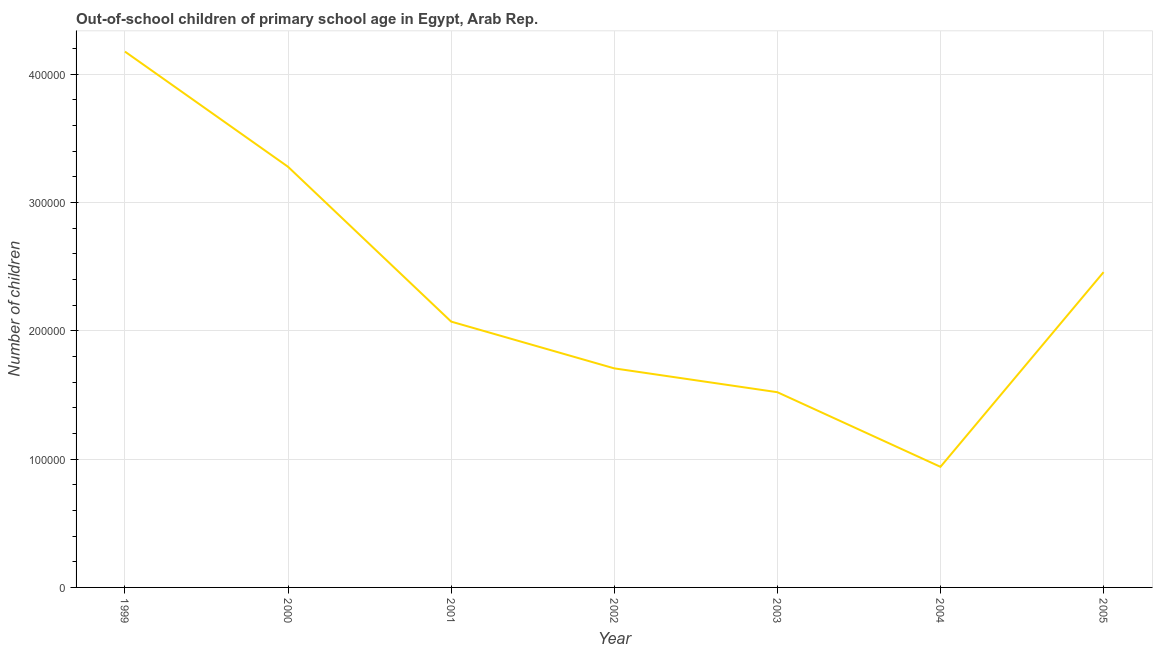What is the number of out-of-school children in 1999?
Your answer should be very brief. 4.18e+05. Across all years, what is the maximum number of out-of-school children?
Your answer should be very brief. 4.18e+05. Across all years, what is the minimum number of out-of-school children?
Your answer should be compact. 9.40e+04. In which year was the number of out-of-school children maximum?
Your answer should be compact. 1999. In which year was the number of out-of-school children minimum?
Provide a short and direct response. 2004. What is the sum of the number of out-of-school children?
Your response must be concise. 1.62e+06. What is the difference between the number of out-of-school children in 1999 and 2002?
Give a very brief answer. 2.47e+05. What is the average number of out-of-school children per year?
Ensure brevity in your answer.  2.31e+05. What is the median number of out-of-school children?
Offer a very short reply. 2.07e+05. Do a majority of the years between 1999 and 2000 (inclusive) have number of out-of-school children greater than 260000 ?
Offer a terse response. Yes. What is the ratio of the number of out-of-school children in 2002 to that in 2005?
Ensure brevity in your answer.  0.69. What is the difference between the highest and the second highest number of out-of-school children?
Give a very brief answer. 8.98e+04. What is the difference between the highest and the lowest number of out-of-school children?
Give a very brief answer. 3.24e+05. How many lines are there?
Your response must be concise. 1. How many years are there in the graph?
Give a very brief answer. 7. What is the difference between two consecutive major ticks on the Y-axis?
Offer a very short reply. 1.00e+05. Are the values on the major ticks of Y-axis written in scientific E-notation?
Your answer should be very brief. No. What is the title of the graph?
Give a very brief answer. Out-of-school children of primary school age in Egypt, Arab Rep. What is the label or title of the X-axis?
Your answer should be compact. Year. What is the label or title of the Y-axis?
Give a very brief answer. Number of children. What is the Number of children of 1999?
Your response must be concise. 4.18e+05. What is the Number of children in 2000?
Your response must be concise. 3.28e+05. What is the Number of children of 2001?
Ensure brevity in your answer.  2.07e+05. What is the Number of children of 2002?
Provide a succinct answer. 1.71e+05. What is the Number of children in 2003?
Give a very brief answer. 1.52e+05. What is the Number of children of 2004?
Give a very brief answer. 9.40e+04. What is the Number of children of 2005?
Provide a short and direct response. 2.46e+05. What is the difference between the Number of children in 1999 and 2000?
Your answer should be compact. 8.98e+04. What is the difference between the Number of children in 1999 and 2001?
Provide a succinct answer. 2.10e+05. What is the difference between the Number of children in 1999 and 2002?
Offer a terse response. 2.47e+05. What is the difference between the Number of children in 1999 and 2003?
Offer a terse response. 2.66e+05. What is the difference between the Number of children in 1999 and 2004?
Offer a terse response. 3.24e+05. What is the difference between the Number of children in 1999 and 2005?
Your answer should be very brief. 1.72e+05. What is the difference between the Number of children in 2000 and 2001?
Offer a terse response. 1.21e+05. What is the difference between the Number of children in 2000 and 2002?
Keep it short and to the point. 1.57e+05. What is the difference between the Number of children in 2000 and 2003?
Your response must be concise. 1.76e+05. What is the difference between the Number of children in 2000 and 2004?
Provide a succinct answer. 2.34e+05. What is the difference between the Number of children in 2000 and 2005?
Ensure brevity in your answer.  8.21e+04. What is the difference between the Number of children in 2001 and 2002?
Give a very brief answer. 3.65e+04. What is the difference between the Number of children in 2001 and 2003?
Your answer should be very brief. 5.50e+04. What is the difference between the Number of children in 2001 and 2004?
Give a very brief answer. 1.13e+05. What is the difference between the Number of children in 2001 and 2005?
Provide a short and direct response. -3.85e+04. What is the difference between the Number of children in 2002 and 2003?
Give a very brief answer. 1.86e+04. What is the difference between the Number of children in 2002 and 2004?
Make the answer very short. 7.68e+04. What is the difference between the Number of children in 2002 and 2005?
Offer a very short reply. -7.50e+04. What is the difference between the Number of children in 2003 and 2004?
Make the answer very short. 5.82e+04. What is the difference between the Number of children in 2003 and 2005?
Offer a very short reply. -9.36e+04. What is the difference between the Number of children in 2004 and 2005?
Your response must be concise. -1.52e+05. What is the ratio of the Number of children in 1999 to that in 2000?
Ensure brevity in your answer.  1.27. What is the ratio of the Number of children in 1999 to that in 2001?
Ensure brevity in your answer.  2.02. What is the ratio of the Number of children in 1999 to that in 2002?
Keep it short and to the point. 2.45. What is the ratio of the Number of children in 1999 to that in 2003?
Keep it short and to the point. 2.75. What is the ratio of the Number of children in 1999 to that in 2004?
Ensure brevity in your answer.  4.44. What is the ratio of the Number of children in 1999 to that in 2005?
Your answer should be very brief. 1.7. What is the ratio of the Number of children in 2000 to that in 2001?
Offer a very short reply. 1.58. What is the ratio of the Number of children in 2000 to that in 2002?
Give a very brief answer. 1.92. What is the ratio of the Number of children in 2000 to that in 2003?
Ensure brevity in your answer.  2.15. What is the ratio of the Number of children in 2000 to that in 2004?
Offer a terse response. 3.49. What is the ratio of the Number of children in 2000 to that in 2005?
Offer a terse response. 1.33. What is the ratio of the Number of children in 2001 to that in 2002?
Offer a terse response. 1.21. What is the ratio of the Number of children in 2001 to that in 2003?
Your answer should be very brief. 1.36. What is the ratio of the Number of children in 2001 to that in 2004?
Your answer should be compact. 2.2. What is the ratio of the Number of children in 2001 to that in 2005?
Provide a succinct answer. 0.84. What is the ratio of the Number of children in 2002 to that in 2003?
Offer a terse response. 1.12. What is the ratio of the Number of children in 2002 to that in 2004?
Offer a terse response. 1.82. What is the ratio of the Number of children in 2002 to that in 2005?
Ensure brevity in your answer.  0.69. What is the ratio of the Number of children in 2003 to that in 2004?
Provide a short and direct response. 1.62. What is the ratio of the Number of children in 2003 to that in 2005?
Your response must be concise. 0.62. What is the ratio of the Number of children in 2004 to that in 2005?
Offer a terse response. 0.38. 